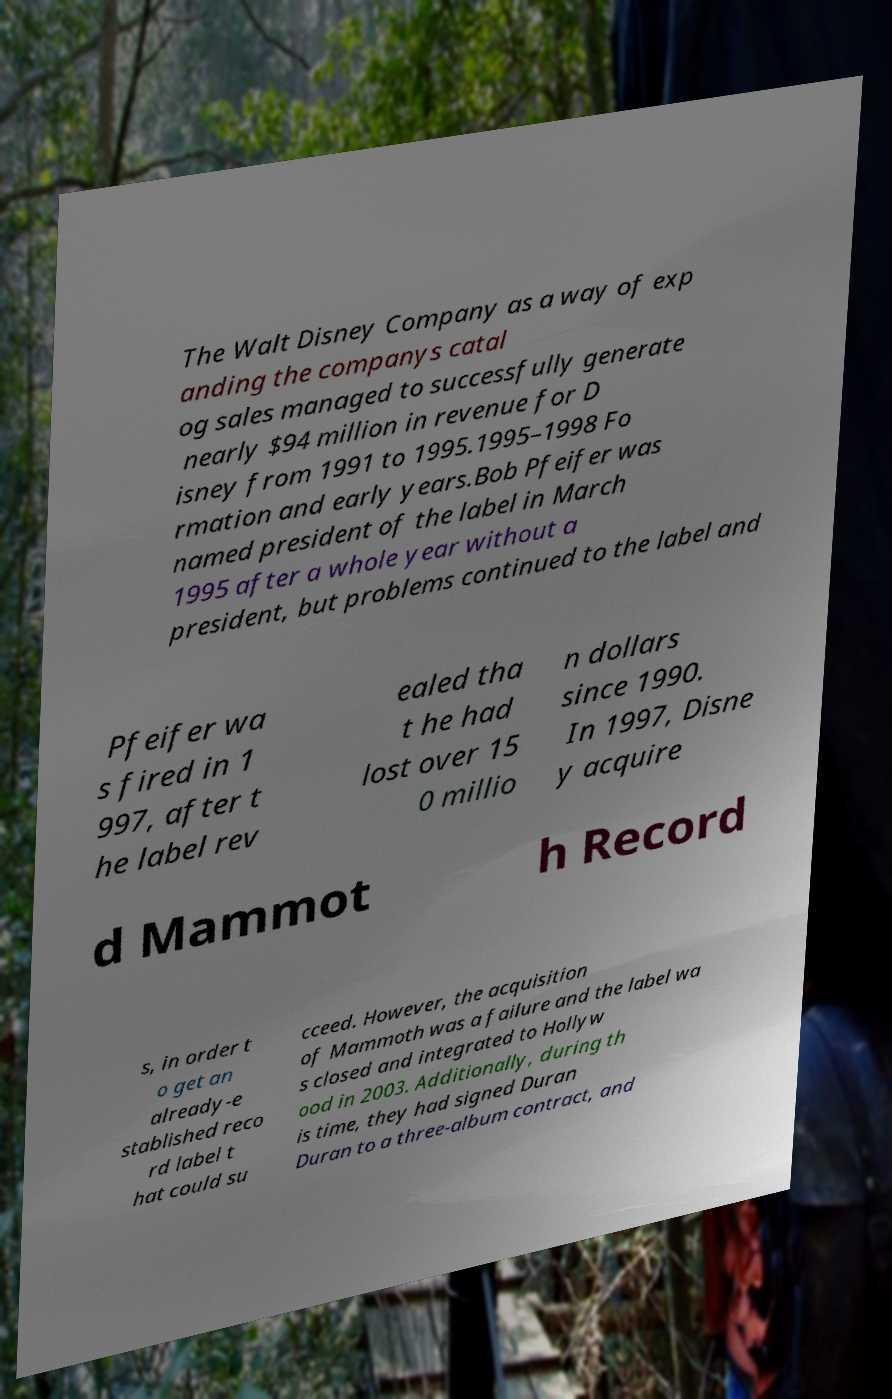What messages or text are displayed in this image? I need them in a readable, typed format. The Walt Disney Company as a way of exp anding the companys catal og sales managed to successfully generate nearly $94 million in revenue for D isney from 1991 to 1995.1995–1998 Fo rmation and early years.Bob Pfeifer was named president of the label in March 1995 after a whole year without a president, but problems continued to the label and Pfeifer wa s fired in 1 997, after t he label rev ealed tha t he had lost over 15 0 millio n dollars since 1990. In 1997, Disne y acquire d Mammot h Record s, in order t o get an already-e stablished reco rd label t hat could su cceed. However, the acquisition of Mammoth was a failure and the label wa s closed and integrated to Hollyw ood in 2003. Additionally, during th is time, they had signed Duran Duran to a three-album contract, and 